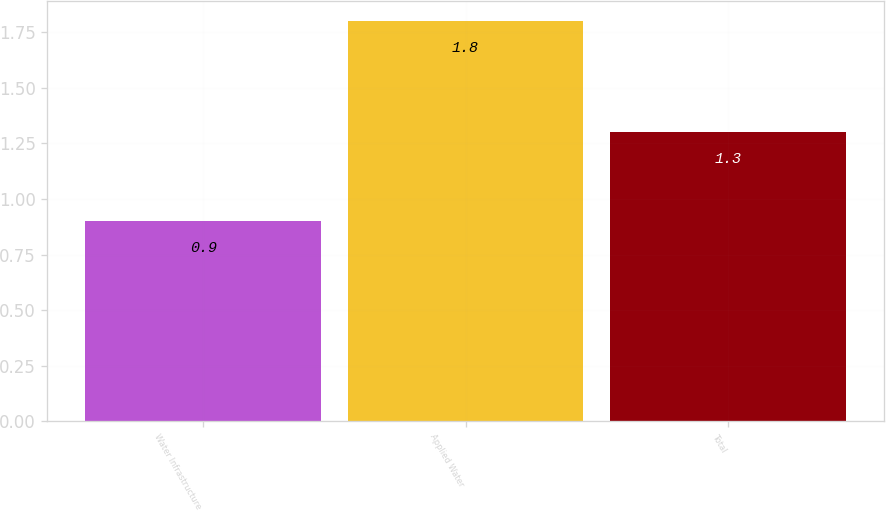Convert chart. <chart><loc_0><loc_0><loc_500><loc_500><bar_chart><fcel>Water Infrastructure<fcel>Applied Water<fcel>Total<nl><fcel>0.9<fcel>1.8<fcel>1.3<nl></chart> 